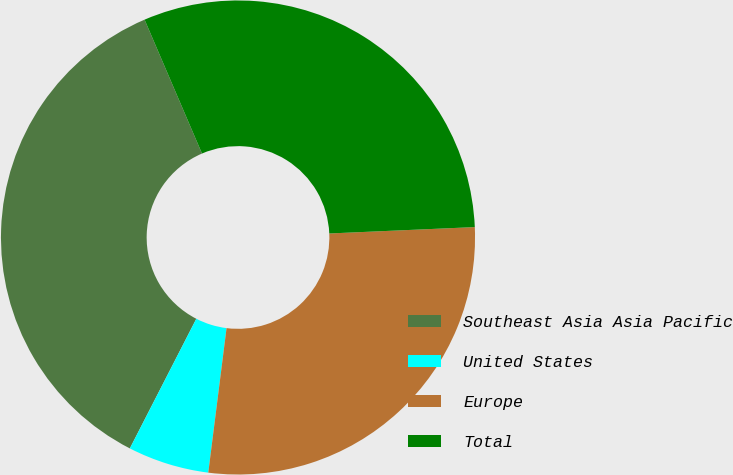Convert chart to OTSL. <chart><loc_0><loc_0><loc_500><loc_500><pie_chart><fcel>Southeast Asia Asia Pacific<fcel>United States<fcel>Europe<fcel>Total<nl><fcel>36.01%<fcel>5.54%<fcel>27.7%<fcel>30.75%<nl></chart> 